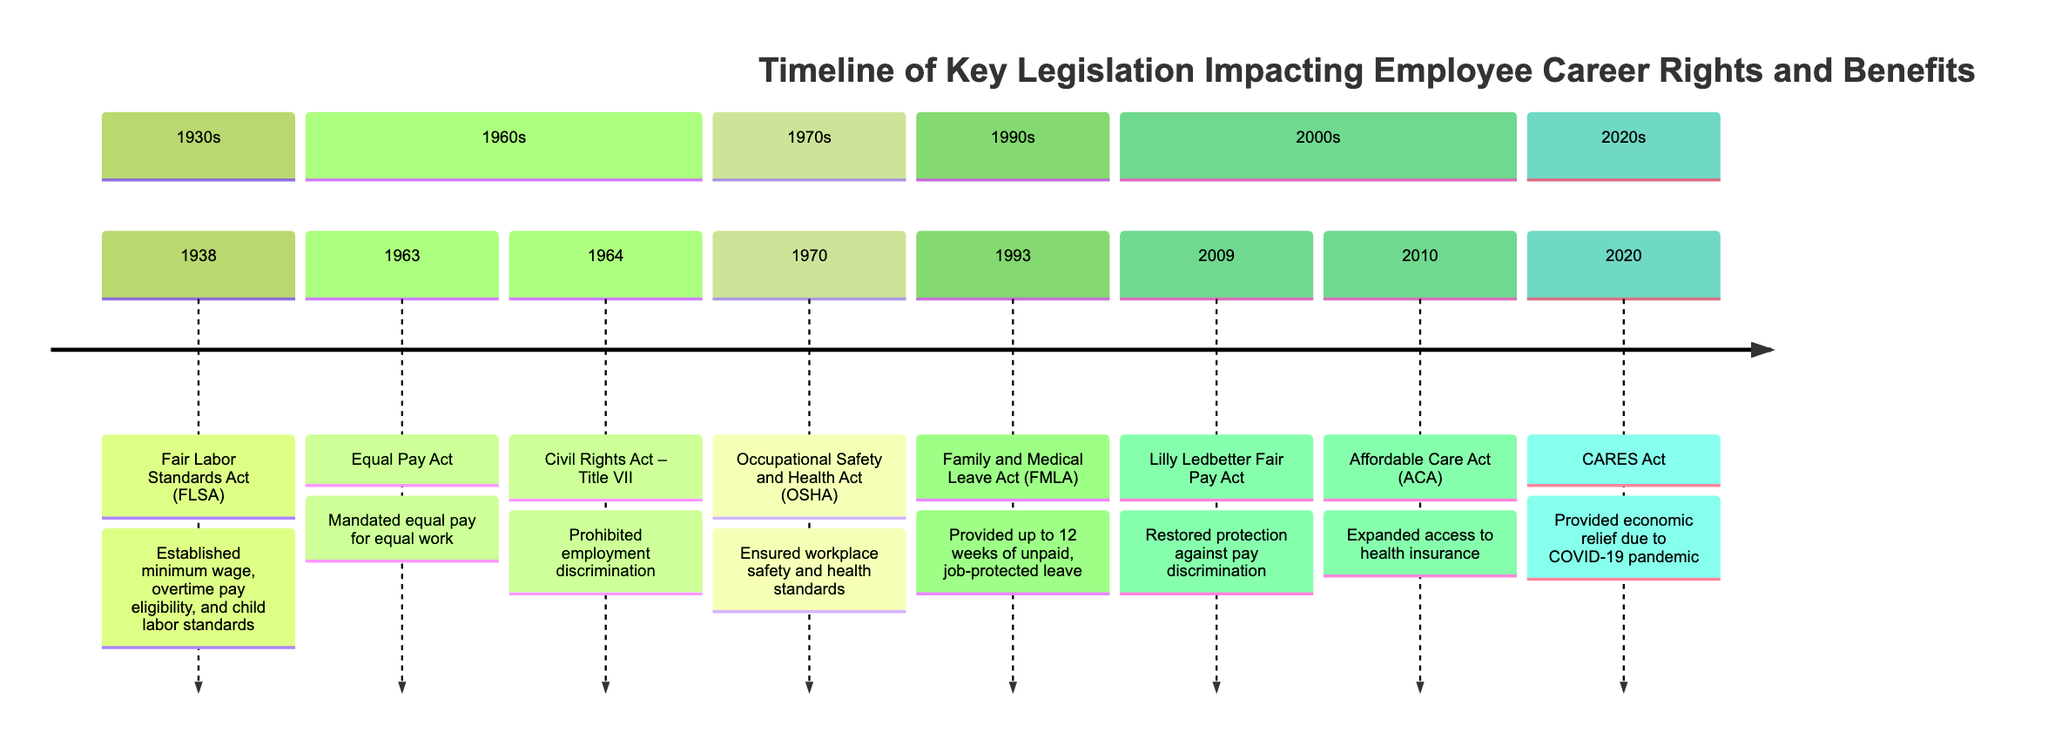What year was the Fair Labor Standards Act enacted? The diagram indicates that the Fair Labor Standards Act was enacted in 1938, as it is listed as the first element in the timeline.
Answer: 1938 What legislation was established in 1964? The diagram shows that in 1964, the Civil Rights Act – Title VII was enacted, which is a key point in the timeline specifically designated for that year.
Answer: Civil Rights Act – Title VII How many pieces of legislation are shown in the timeline? By counting the number of timeline elements presented in the data, there are a total of 8 distinct pieces of legislation represented.
Answer: 8 What does the Family and Medical Leave Act allow employees to do? According to the timeline, the Family and Medical Leave Act allows employees to take up to 12 weeks of unpaid, job-protected leave for specific family and medical reasons, as described in the 1993 section.
Answer: Take up to 12 weeks of unpaid leave Which act restored protection against pay discrimination in 2009? The only act mentioned in the timeline for the year 2009 is the Lilly Ledbetter Fair Pay Act, which specifically addresses pay discrimination protections.
Answer: Lilly Ledbetter Fair Pay Act What significant legislation was introduced due to the COVID-19 pandemic? The timeline indicates that the CARES Act, enacted in 2020, was introduced to provide economic relief related to the impacts of the COVID-19 pandemic, making it the key legislation in that year.
Answer: CARES Act Which legislation aimed specifically at workplace safety? The Occupational Safety and Health Act, listed in 1970, directly addresses workplace safety and health standards, making it the relevant legislation for that query.
Answer: Occupational Safety and Health Act (OSHA) What is the earliest piece of legislation affecting employee rights listed in the timeline? The timeline starts with the Fair Labor Standards Act from 1938, making it the earliest legislation impacting employee rights included in the diagram.
Answer: Fair Labor Standards Act (FLSA) 